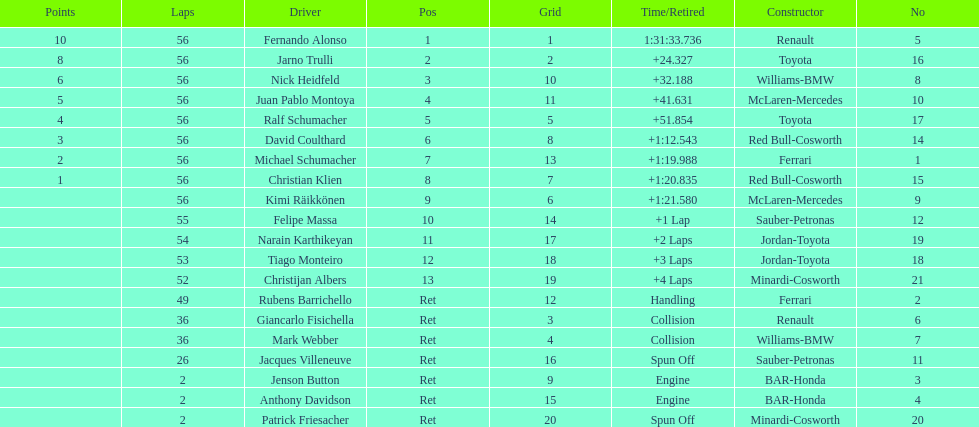How long did it take for heidfeld to finish? 1:31:65.924. 